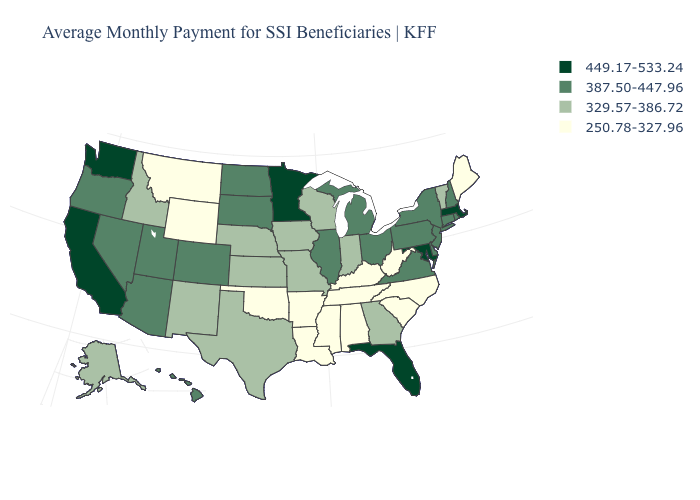What is the value of New Jersey?
Be succinct. 387.50-447.96. What is the value of New Mexico?
Give a very brief answer. 329.57-386.72. Name the states that have a value in the range 387.50-447.96?
Write a very short answer. Arizona, Colorado, Connecticut, Delaware, Hawaii, Illinois, Michigan, Nevada, New Hampshire, New Jersey, New York, North Dakota, Ohio, Oregon, Pennsylvania, Rhode Island, South Dakota, Utah, Virginia. Among the states that border Texas , does Arkansas have the lowest value?
Give a very brief answer. Yes. Does Hawaii have the lowest value in the USA?
Answer briefly. No. What is the lowest value in states that border Kentucky?
Give a very brief answer. 250.78-327.96. What is the highest value in the USA?
Keep it brief. 449.17-533.24. Does Indiana have a lower value than Florida?
Concise answer only. Yes. Name the states that have a value in the range 250.78-327.96?
Write a very short answer. Alabama, Arkansas, Kentucky, Louisiana, Maine, Mississippi, Montana, North Carolina, Oklahoma, South Carolina, Tennessee, West Virginia, Wyoming. Name the states that have a value in the range 449.17-533.24?
Quick response, please. California, Florida, Maryland, Massachusetts, Minnesota, Washington. What is the lowest value in states that border New York?
Quick response, please. 329.57-386.72. Does Massachusetts have the highest value in the Northeast?
Be succinct. Yes. Name the states that have a value in the range 250.78-327.96?
Concise answer only. Alabama, Arkansas, Kentucky, Louisiana, Maine, Mississippi, Montana, North Carolina, Oklahoma, South Carolina, Tennessee, West Virginia, Wyoming. Does the first symbol in the legend represent the smallest category?
Concise answer only. No. 